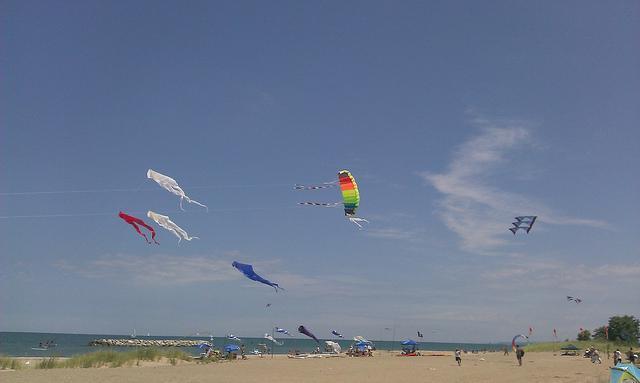How many colors are on the multicolor kite?
Give a very brief answer. 7. 